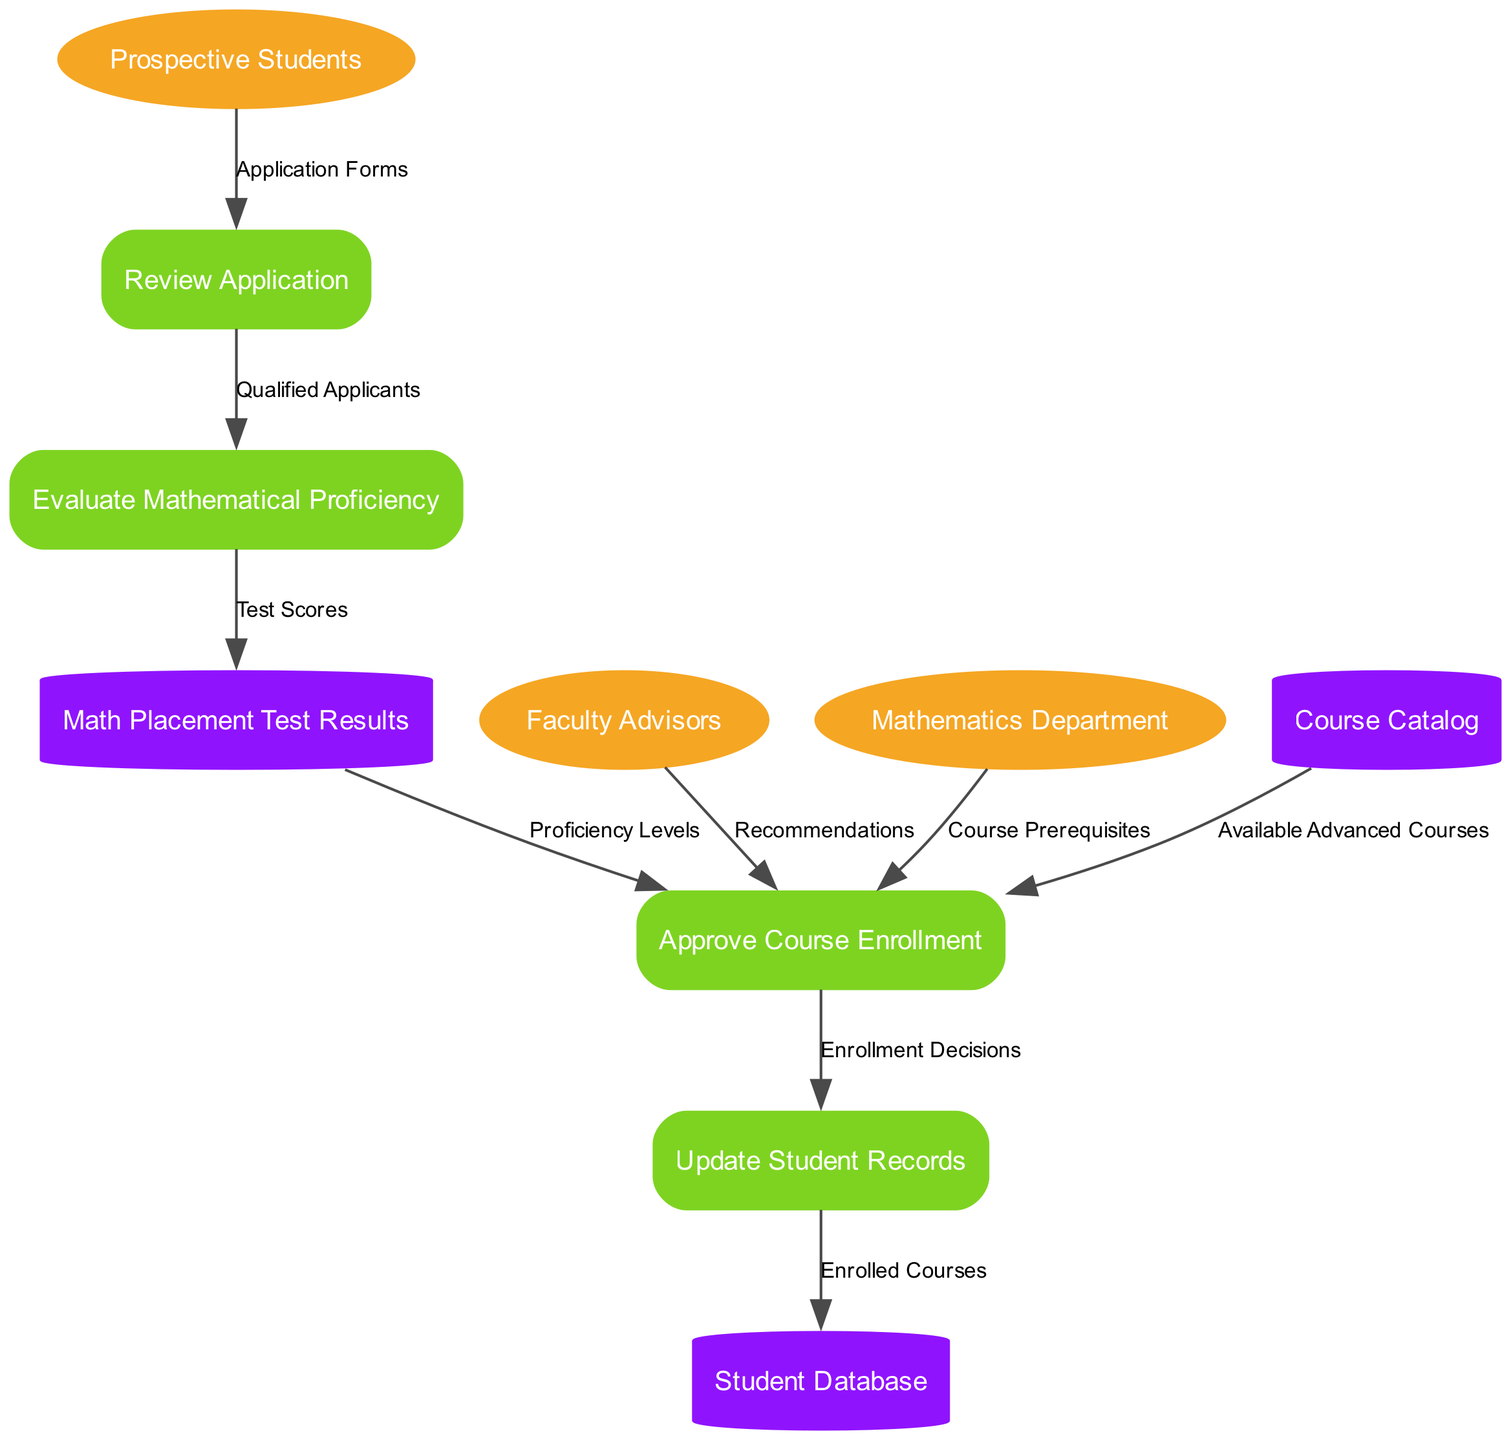What external entities are involved in the student enrollment process? The diagram indicates three external entities: Prospective Students, Faculty Advisors, and Mathematics Department. These are connected to various processes related to student enrollment.
Answer: Prospective Students, Faculty Advisors, Mathematics Department How many processes are shown in the diagram? The diagram lists four distinct processes: Review Application, Evaluate Mathematical Proficiency, Approve Course Enrollment, and Update Student Records. These processes define the steps involved in the enrollment process.
Answer: Four What is the flow of data from Prospective Students to the Review Application process? There is a direct data flow labeled "Application Forms" from Prospective Students to the Review Application process, indicating that students submit their application forms for review.
Answer: Application Forms Which process evaluates the mathematical proficiency of applicants? The process "Evaluate Mathematical Proficiency" is specifically designated for assessing the mathematical skills of applicants based on data processed from the Review Application.
Answer: Evaluate Mathematical Proficiency What data is fed into the Approve Course Enrollment process? The Approve Course Enrollment process receives data flows from three sources: "Proficiency Levels" from Math Placement Test Results, "Available Advanced Courses" from Course Catalog, and "Recommendations" from Faculty Advisors, which determine the approval criteria.
Answer: Proficiency Levels, Available Advanced Courses, Recommendations From which data store does the Approve Course Enrollment process receive available courses? The Approve Course Enrollment process accesses the Course Catalog data store to obtain information about the available advanced courses that students can enroll in.
Answer: Course Catalog What are the final outcomes updated in the Student Database? The Update Student Records process outputs "Enrolled Courses" to the Student Database, reflecting the courses that have been successfully enrolled by the students after completing the previous processes.
Answer: Enrolled Courses Which process receives test scores for evaluation? The Evaluate Mathematical Proficiency process receives data labeled "Test Scores" from the Math Placement Test Results data store, which is essential for assessing applicants' qualifications.
Answer: Evaluate Mathematical Proficiency What prerequisite information is provided to the Approve Course Enrollment process? The process receives "Course Prerequisites" from the Mathematics Department, which outlines the necessary criteria that students must meet to enroll in specific advanced mathematics courses.
Answer: Course Prerequisites 